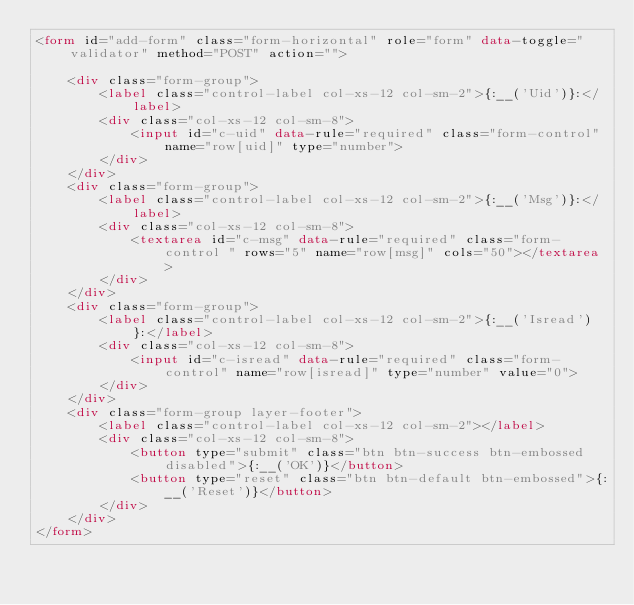Convert code to text. <code><loc_0><loc_0><loc_500><loc_500><_HTML_><form id="add-form" class="form-horizontal" role="form" data-toggle="validator" method="POST" action="">

    <div class="form-group">
        <label class="control-label col-xs-12 col-sm-2">{:__('Uid')}:</label>
        <div class="col-xs-12 col-sm-8">
            <input id="c-uid" data-rule="required" class="form-control" name="row[uid]" type="number">
        </div>
    </div>
    <div class="form-group">
        <label class="control-label col-xs-12 col-sm-2">{:__('Msg')}:</label>
        <div class="col-xs-12 col-sm-8">
            <textarea id="c-msg" data-rule="required" class="form-control " rows="5" name="row[msg]" cols="50"></textarea>
        </div>
    </div>
    <div class="form-group">
        <label class="control-label col-xs-12 col-sm-2">{:__('Isread')}:</label>
        <div class="col-xs-12 col-sm-8">
            <input id="c-isread" data-rule="required" class="form-control" name="row[isread]" type="number" value="0">
        </div>
    </div>
    <div class="form-group layer-footer">
        <label class="control-label col-xs-12 col-sm-2"></label>
        <div class="col-xs-12 col-sm-8">
            <button type="submit" class="btn btn-success btn-embossed disabled">{:__('OK')}</button>
            <button type="reset" class="btn btn-default btn-embossed">{:__('Reset')}</button>
        </div>
    </div>
</form>
</code> 